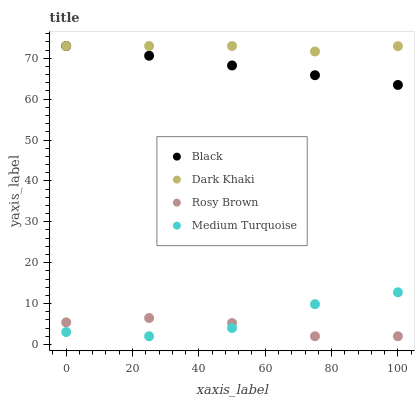Does Rosy Brown have the minimum area under the curve?
Answer yes or no. Yes. Does Dark Khaki have the maximum area under the curve?
Answer yes or no. Yes. Does Black have the minimum area under the curve?
Answer yes or no. No. Does Black have the maximum area under the curve?
Answer yes or no. No. Is Black the smoothest?
Answer yes or no. Yes. Is Medium Turquoise the roughest?
Answer yes or no. Yes. Is Rosy Brown the smoothest?
Answer yes or no. No. Is Rosy Brown the roughest?
Answer yes or no. No. Does Rosy Brown have the lowest value?
Answer yes or no. Yes. Does Black have the lowest value?
Answer yes or no. No. Does Black have the highest value?
Answer yes or no. Yes. Does Rosy Brown have the highest value?
Answer yes or no. No. Is Medium Turquoise less than Black?
Answer yes or no. Yes. Is Dark Khaki greater than Medium Turquoise?
Answer yes or no. Yes. Does Dark Khaki intersect Black?
Answer yes or no. Yes. Is Dark Khaki less than Black?
Answer yes or no. No. Is Dark Khaki greater than Black?
Answer yes or no. No. Does Medium Turquoise intersect Black?
Answer yes or no. No. 